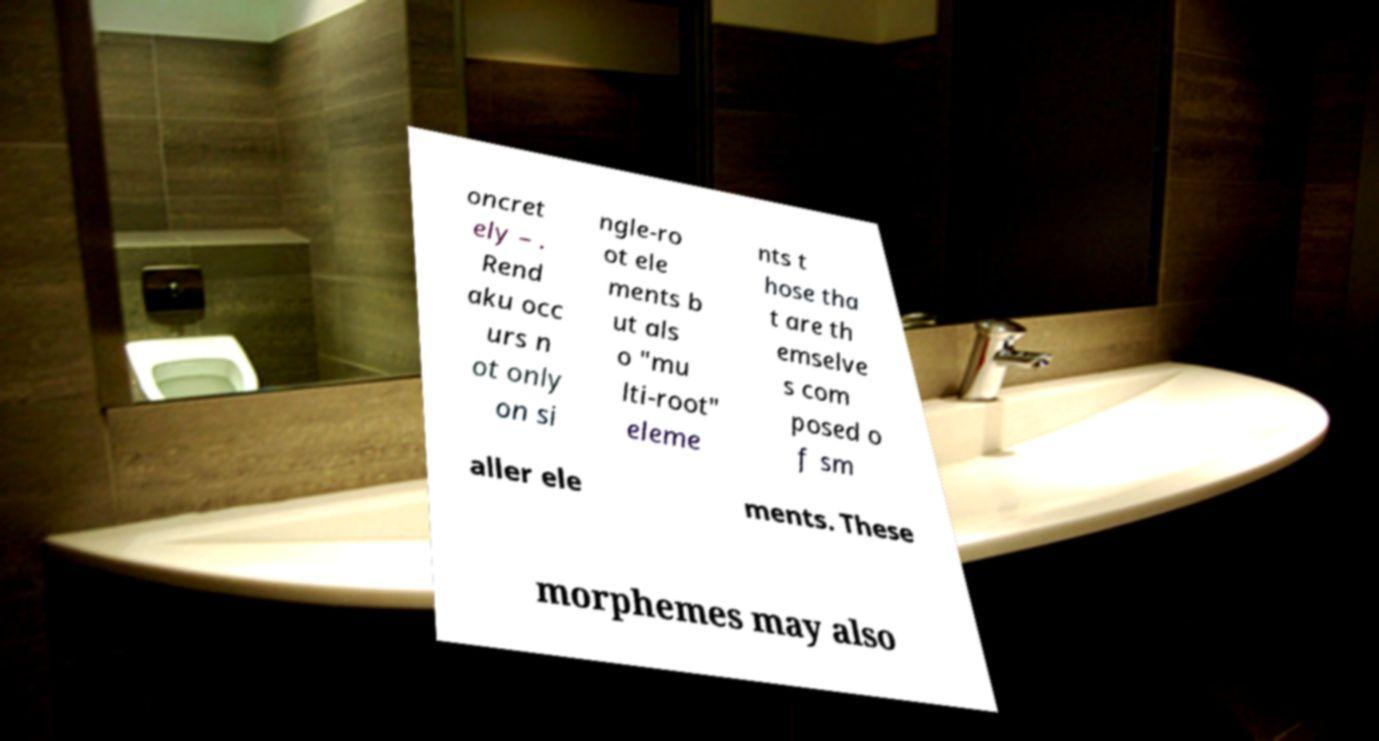Could you assist in decoding the text presented in this image and type it out clearly? oncret ely – . Rend aku occ urs n ot only on si ngle-ro ot ele ments b ut als o "mu lti-root" eleme nts t hose tha t are th emselve s com posed o f sm aller ele ments. These morphemes may also 